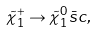<formula> <loc_0><loc_0><loc_500><loc_500>\tilde { \chi } ^ { + } _ { 1 } \to \tilde { \chi } ^ { 0 } _ { 1 } \bar { s } c ,</formula> 